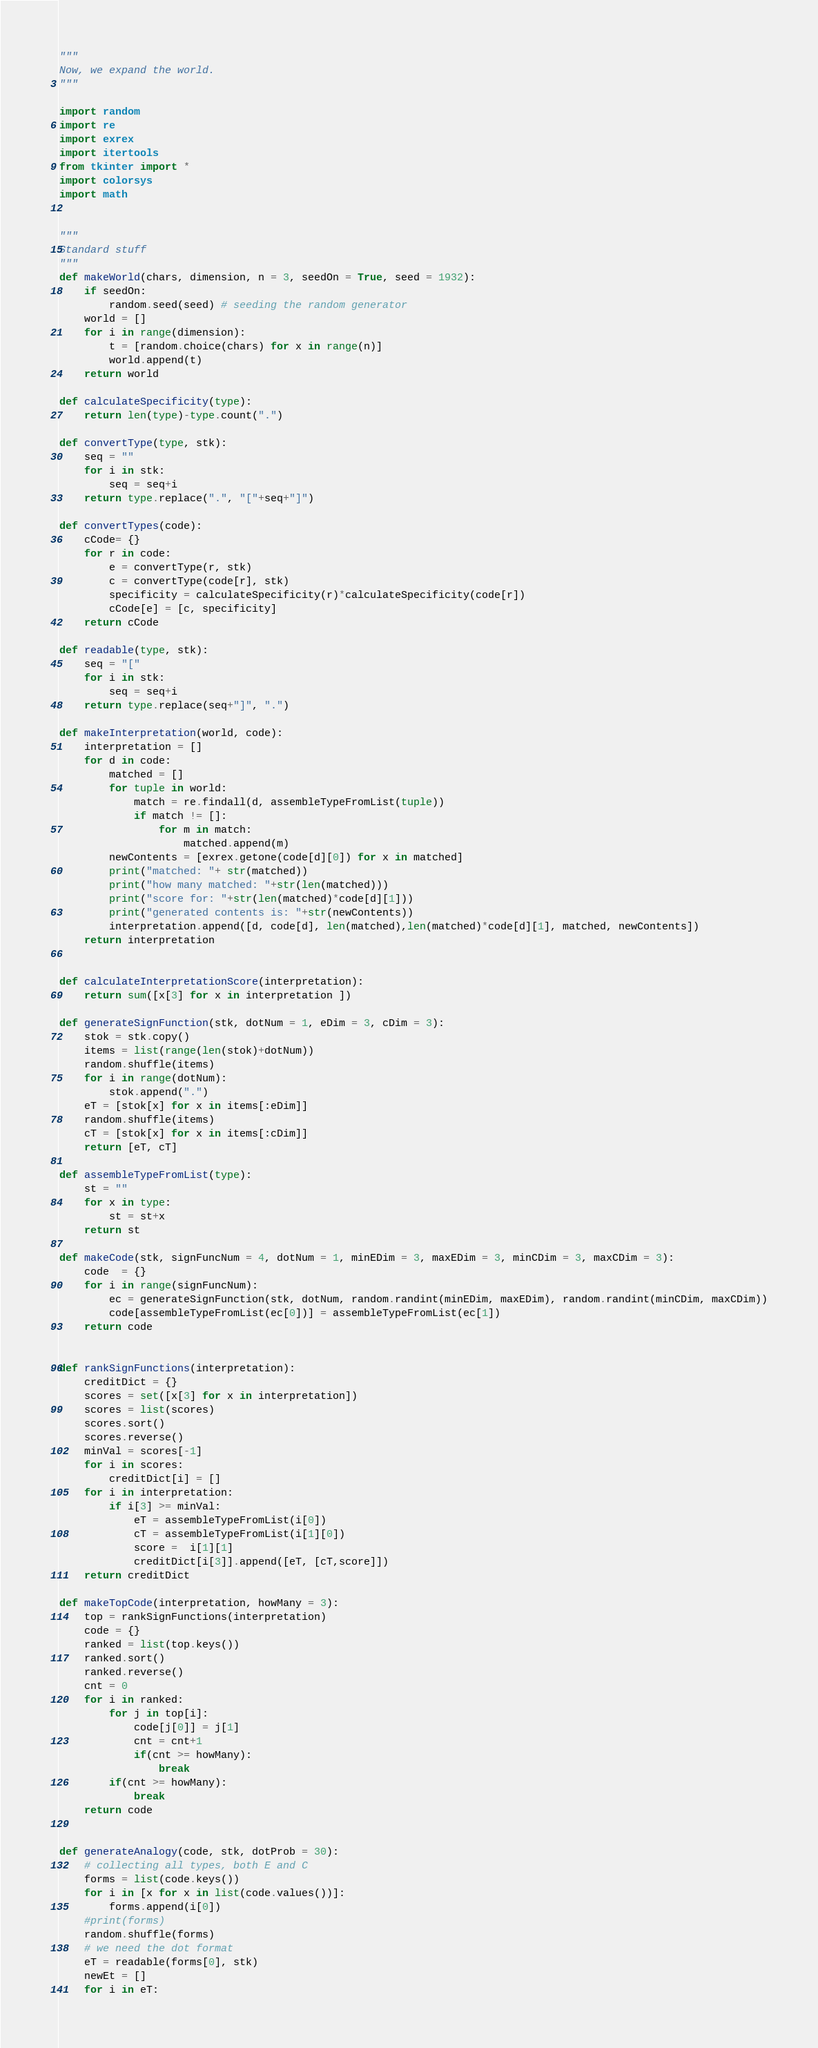<code> <loc_0><loc_0><loc_500><loc_500><_Python_>"""
Now, we expand the world.
"""

import random
import re
import exrex
import itertools
from tkinter import *
import colorsys
import math


"""
Standard stuff
"""
def makeWorld(chars, dimension, n = 3, seedOn = True, seed = 1932):
    if seedOn:
        random.seed(seed) # seeding the random generator
    world = []
    for i in range(dimension):
        t = [random.choice(chars) for x in range(n)]
        world.append(t)
    return world

def calculateSpecificity(type):
    return len(type)-type.count(".")

def convertType(type, stk):
    seq = ""
    for i in stk:
        seq = seq+i
    return type.replace(".", "["+seq+"]")

def convertTypes(code):
    cCode= {}
    for r in code:
        e = convertType(r, stk)
        c = convertType(code[r], stk)
        specificity = calculateSpecificity(r)*calculateSpecificity(code[r])
        cCode[e] = [c, specificity]
    return cCode

def readable(type, stk):
    seq = "["
    for i in stk:
        seq = seq+i
    return type.replace(seq+"]", ".")

def makeInterpretation(world, code):
    interpretation = []
    for d in code:
        matched = []
        for tuple in world:
            match = re.findall(d, assembleTypeFromList(tuple))
            if match != []:
                for m in match:
                    matched.append(m)
        newContents = [exrex.getone(code[d][0]) for x in matched]
        print("matched: "+ str(matched))
        print("how many matched: "+str(len(matched)))
        print("score for: "+str(len(matched)*code[d][1]))
        print("generated contents is: "+str(newContents))
        interpretation.append([d, code[d], len(matched),len(matched)*code[d][1], matched, newContents])
    return interpretation


def calculateInterpretationScore(interpretation):
    return sum([x[3] for x in interpretation ])

def generateSignFunction(stk, dotNum = 1, eDim = 3, cDim = 3):
    stok = stk.copy()
    items = list(range(len(stok)+dotNum))
    random.shuffle(items)
    for i in range(dotNum):
        stok.append(".")
    eT = [stok[x] for x in items[:eDim]]
    random.shuffle(items)
    cT = [stok[x] for x in items[:cDim]]
    return [eT, cT]

def assembleTypeFromList(type):
    st = ""
    for x in type:
        st = st+x
    return st

def makeCode(stk, signFuncNum = 4, dotNum = 1, minEDim = 3, maxEDim = 3, minCDim = 3, maxCDim = 3):
    code  = {}
    for i in range(signFuncNum):
        ec = generateSignFunction(stk, dotNum, random.randint(minEDim, maxEDim), random.randint(minCDim, maxCDim))
        code[assembleTypeFromList(ec[0])] = assembleTypeFromList(ec[1])
    return code


def rankSignFunctions(interpretation):
    creditDict = {}
    scores = set([x[3] for x in interpretation])
    scores = list(scores)
    scores.sort()
    scores.reverse()
    minVal = scores[-1]
    for i in scores:
        creditDict[i] = []
    for i in interpretation:
        if i[3] >= minVal:
            eT = assembleTypeFromList(i[0])
            cT = assembleTypeFromList(i[1][0])
            score =  i[1][1]
            creditDict[i[3]].append([eT, [cT,score]])
    return creditDict

def makeTopCode(interpretation, howMany = 3):
    top = rankSignFunctions(interpretation)
    code = {}
    ranked = list(top.keys())
    ranked.sort()
    ranked.reverse()
    cnt = 0
    for i in ranked:
        for j in top[i]:
            code[j[0]] = j[1]
            cnt = cnt+1
            if(cnt >= howMany):
                break
        if(cnt >= howMany):
            break
    return code


def generateAnalogy(code, stk, dotProb = 30):
    # collecting all types, both E and C
    forms = list(code.keys())
    for i in [x for x in list(code.values())]:
        forms.append(i[0])
    #print(forms)
    random.shuffle(forms)
    # we need the dot format
    eT = readable(forms[0], stk)
    newEt = []
    for i in eT:</code> 